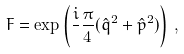Convert formula to latex. <formula><loc_0><loc_0><loc_500><loc_500>F = \exp \left ( \frac { i } { } \frac { \pi } { 4 } ( \hat { q } ^ { 2 } + \hat { p } ^ { 2 } ) \right ) \, ,</formula> 